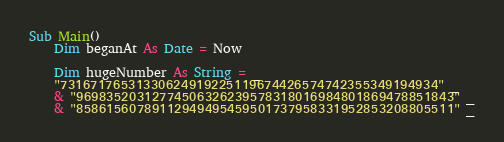<code> <loc_0><loc_0><loc_500><loc_500><_VisualBasic_>Sub Main()
    Dim beganAt As Date = Now

    Dim hugeNumber As String = _
    "73167176531330624919225119674426574742355349194934" _
    & "96983520312774506326239578318016984801869478851843" _
    & "85861560789112949495459501737958331952853208805511" _</code> 